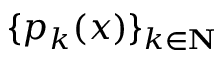<formula> <loc_0><loc_0><loc_500><loc_500>\{ p _ { k } ( x ) \} _ { k \in N }</formula> 